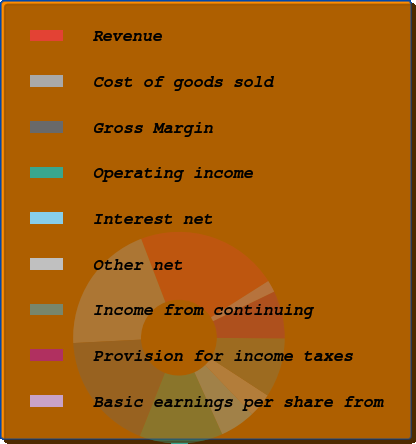Convert chart to OTSL. <chart><loc_0><loc_0><loc_500><loc_500><pie_chart><fcel>Revenue<fcel>Cost of goods sold<fcel>Gross Margin<fcel>Operating income<fcel>Interest net<fcel>Other net<fcel>Income from continuing<fcel>Provision for income taxes<fcel>Basic earnings per share from<nl><fcel>21.82%<fcel>20.0%<fcel>18.18%<fcel>12.73%<fcel>5.45%<fcel>3.64%<fcel>9.09%<fcel>7.27%<fcel>1.82%<nl></chart> 